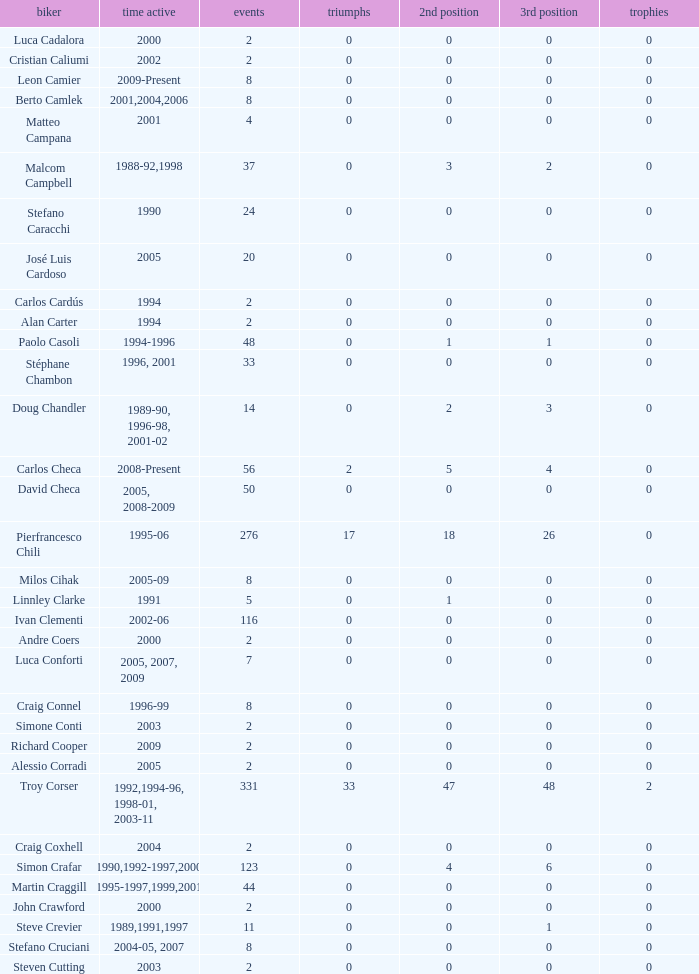What is the total number of wins for riders with fewer than 56 races and more than 0 titles? 0.0. 